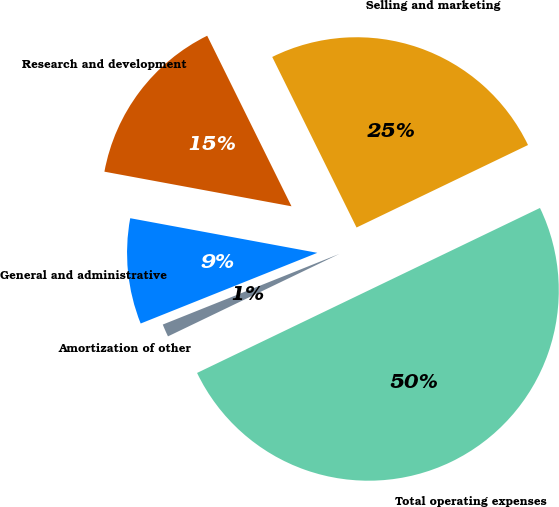<chart> <loc_0><loc_0><loc_500><loc_500><pie_chart><fcel>Selling and marketing<fcel>Research and development<fcel>General and administrative<fcel>Amortization of other<fcel>Total operating expenses<nl><fcel>25.17%<fcel>14.78%<fcel>8.97%<fcel>1.08%<fcel>50.0%<nl></chart> 